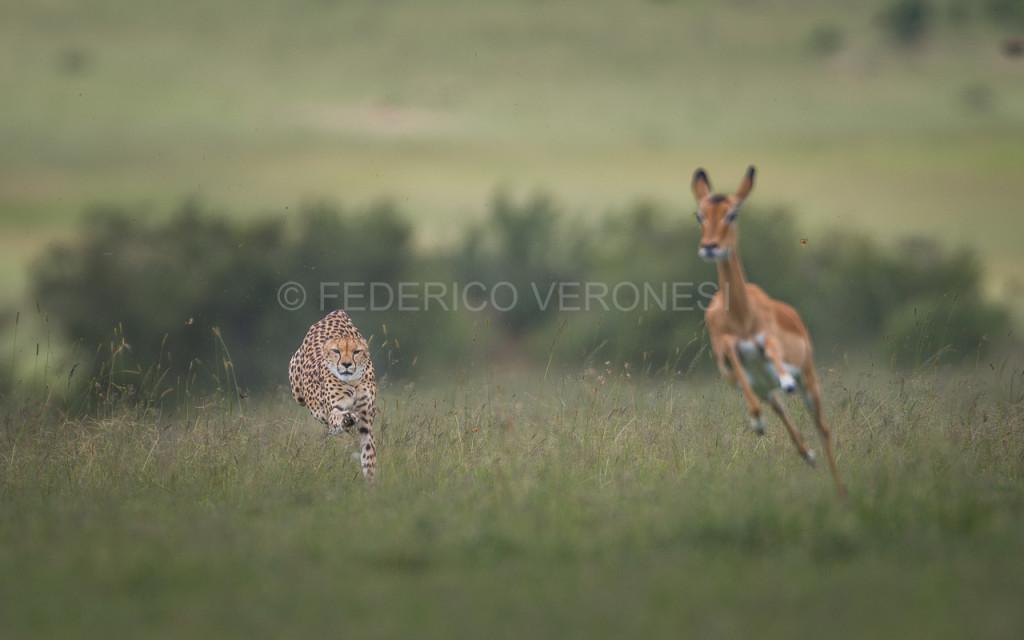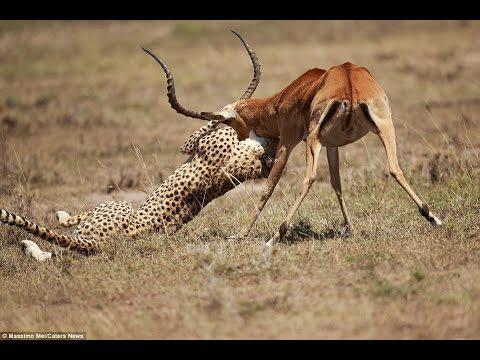The first image is the image on the left, the second image is the image on the right. Evaluate the accuracy of this statement regarding the images: "One leopard is chasing a young deer while another leopard will have antelope for the meal.". Is it true? Answer yes or no. Yes. 